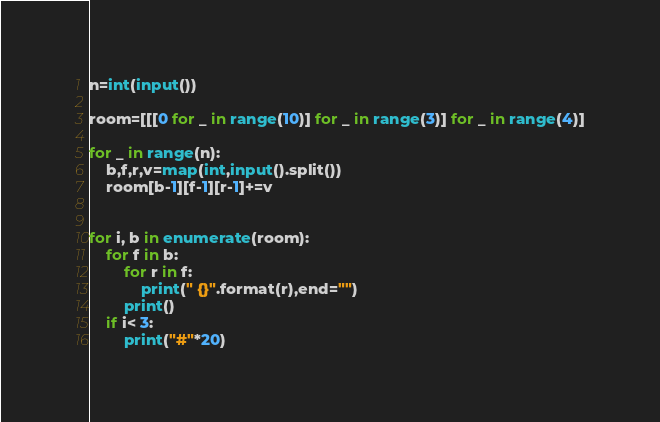Convert code to text. <code><loc_0><loc_0><loc_500><loc_500><_Python_>n=int(input())

room=[[[0 for _ in range(10)] for _ in range(3)] for _ in range(4)]

for _ in range(n):
    b,f,r,v=map(int,input().split())
    room[b-1][f-1][r-1]+=v


for i, b in enumerate(room):
    for f in b:
        for r in f:
            print(" {}".format(r),end="")
        print()
    if i< 3:
        print("#"*20)
</code> 